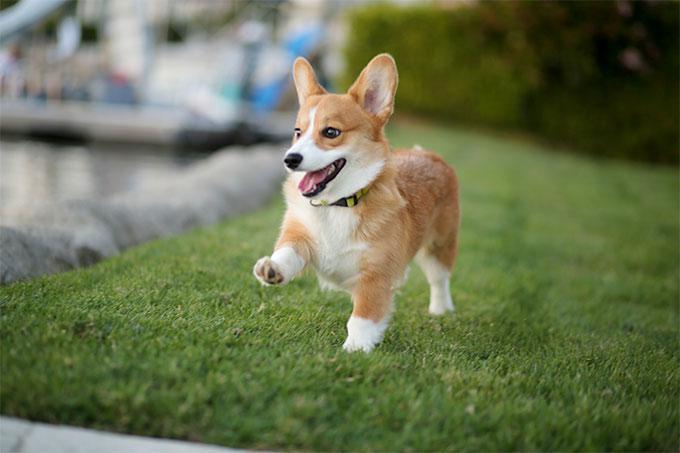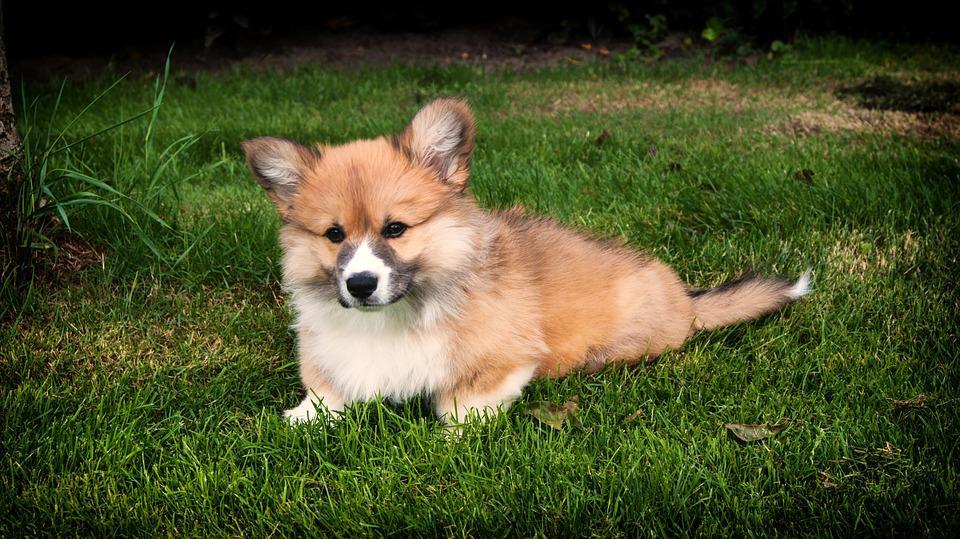The first image is the image on the left, the second image is the image on the right. Evaluate the accuracy of this statement regarding the images: "An image shows a corgi standing in grass with leftward foot raised.". Is it true? Answer yes or no. Yes. The first image is the image on the left, the second image is the image on the right. Considering the images on both sides, is "In the left image there is a dog with its front paw up." valid? Answer yes or no. Yes. The first image is the image on the left, the second image is the image on the right. Given the left and right images, does the statement "One of the dogs is lying in the grass." hold true? Answer yes or no. Yes. 